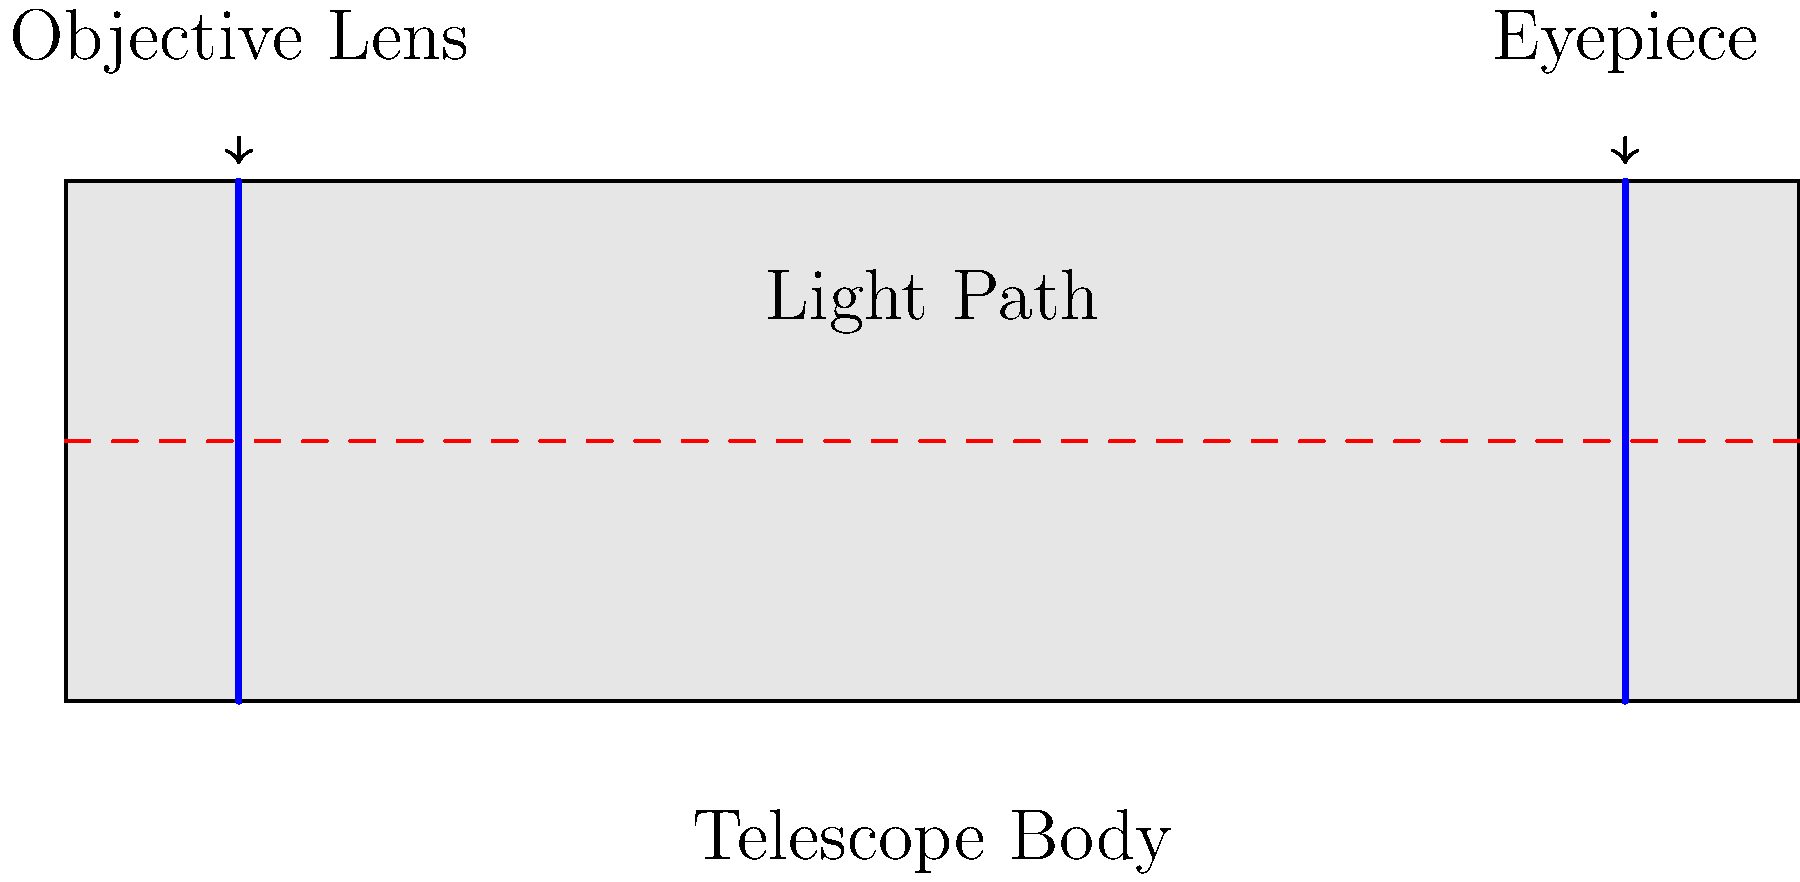In a refracting telescope, what is the primary function of the objective lens, and how does it differ from the eyepiece? To understand the function of the objective lens in a refracting telescope, let's break it down step-by-step:

1. Objective Lens:
   - Located at the front of the telescope (left side in the diagram)
   - Larger in diameter compared to the eyepiece
   - Primary function: Collects and focuses light from distant objects

2. Light Collection:
   - The objective lens gathers more light than the human eye can
   - Larger diameter allows for more light collection, making dim objects visible

3. Focusing:
   - Bends (refracts) incoming light rays
   - Creates a focused image at its focal point inside the telescope tube

4. Magnification:
   - The objective lens itself doesn't magnify the image
   - It creates a larger, brighter real image inside the telescope

5. Eyepiece Function:
   - Located at the back of the telescope (right side in the diagram)
   - Smaller in diameter compared to the objective lens
   - Acts as a magnifying glass for the real image formed by the objective lens
   - Produces the final magnified virtual image seen by the observer

6. Key Difference:
   - Objective lens: Collects light and forms a real image
   - Eyepiece: Magnifies the real image formed by the objective lens

In summary, the objective lens collects and focuses light to form a real image, while the eyepiece magnifies this image for viewing.
Answer: Collects and focuses light; eyepiece magnifies 